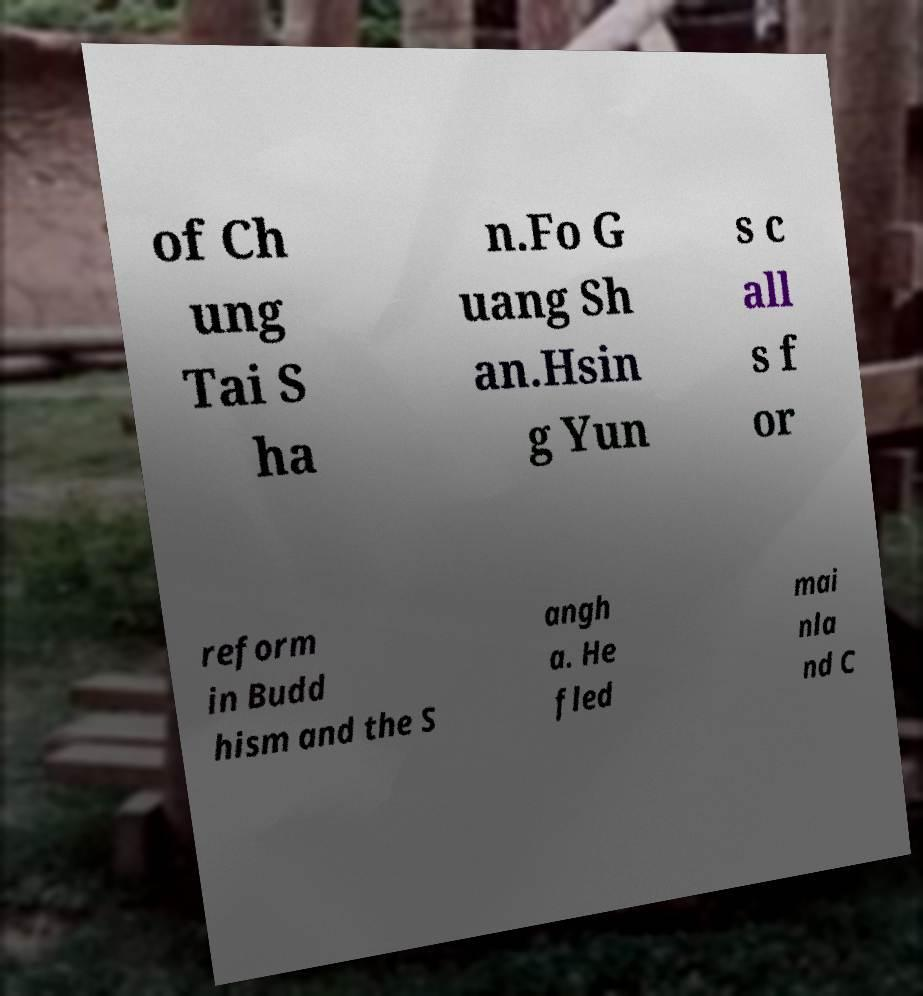Can you accurately transcribe the text from the provided image for me? of Ch ung Tai S ha n.Fo G uang Sh an.Hsin g Yun s c all s f or reform in Budd hism and the S angh a. He fled mai nla nd C 